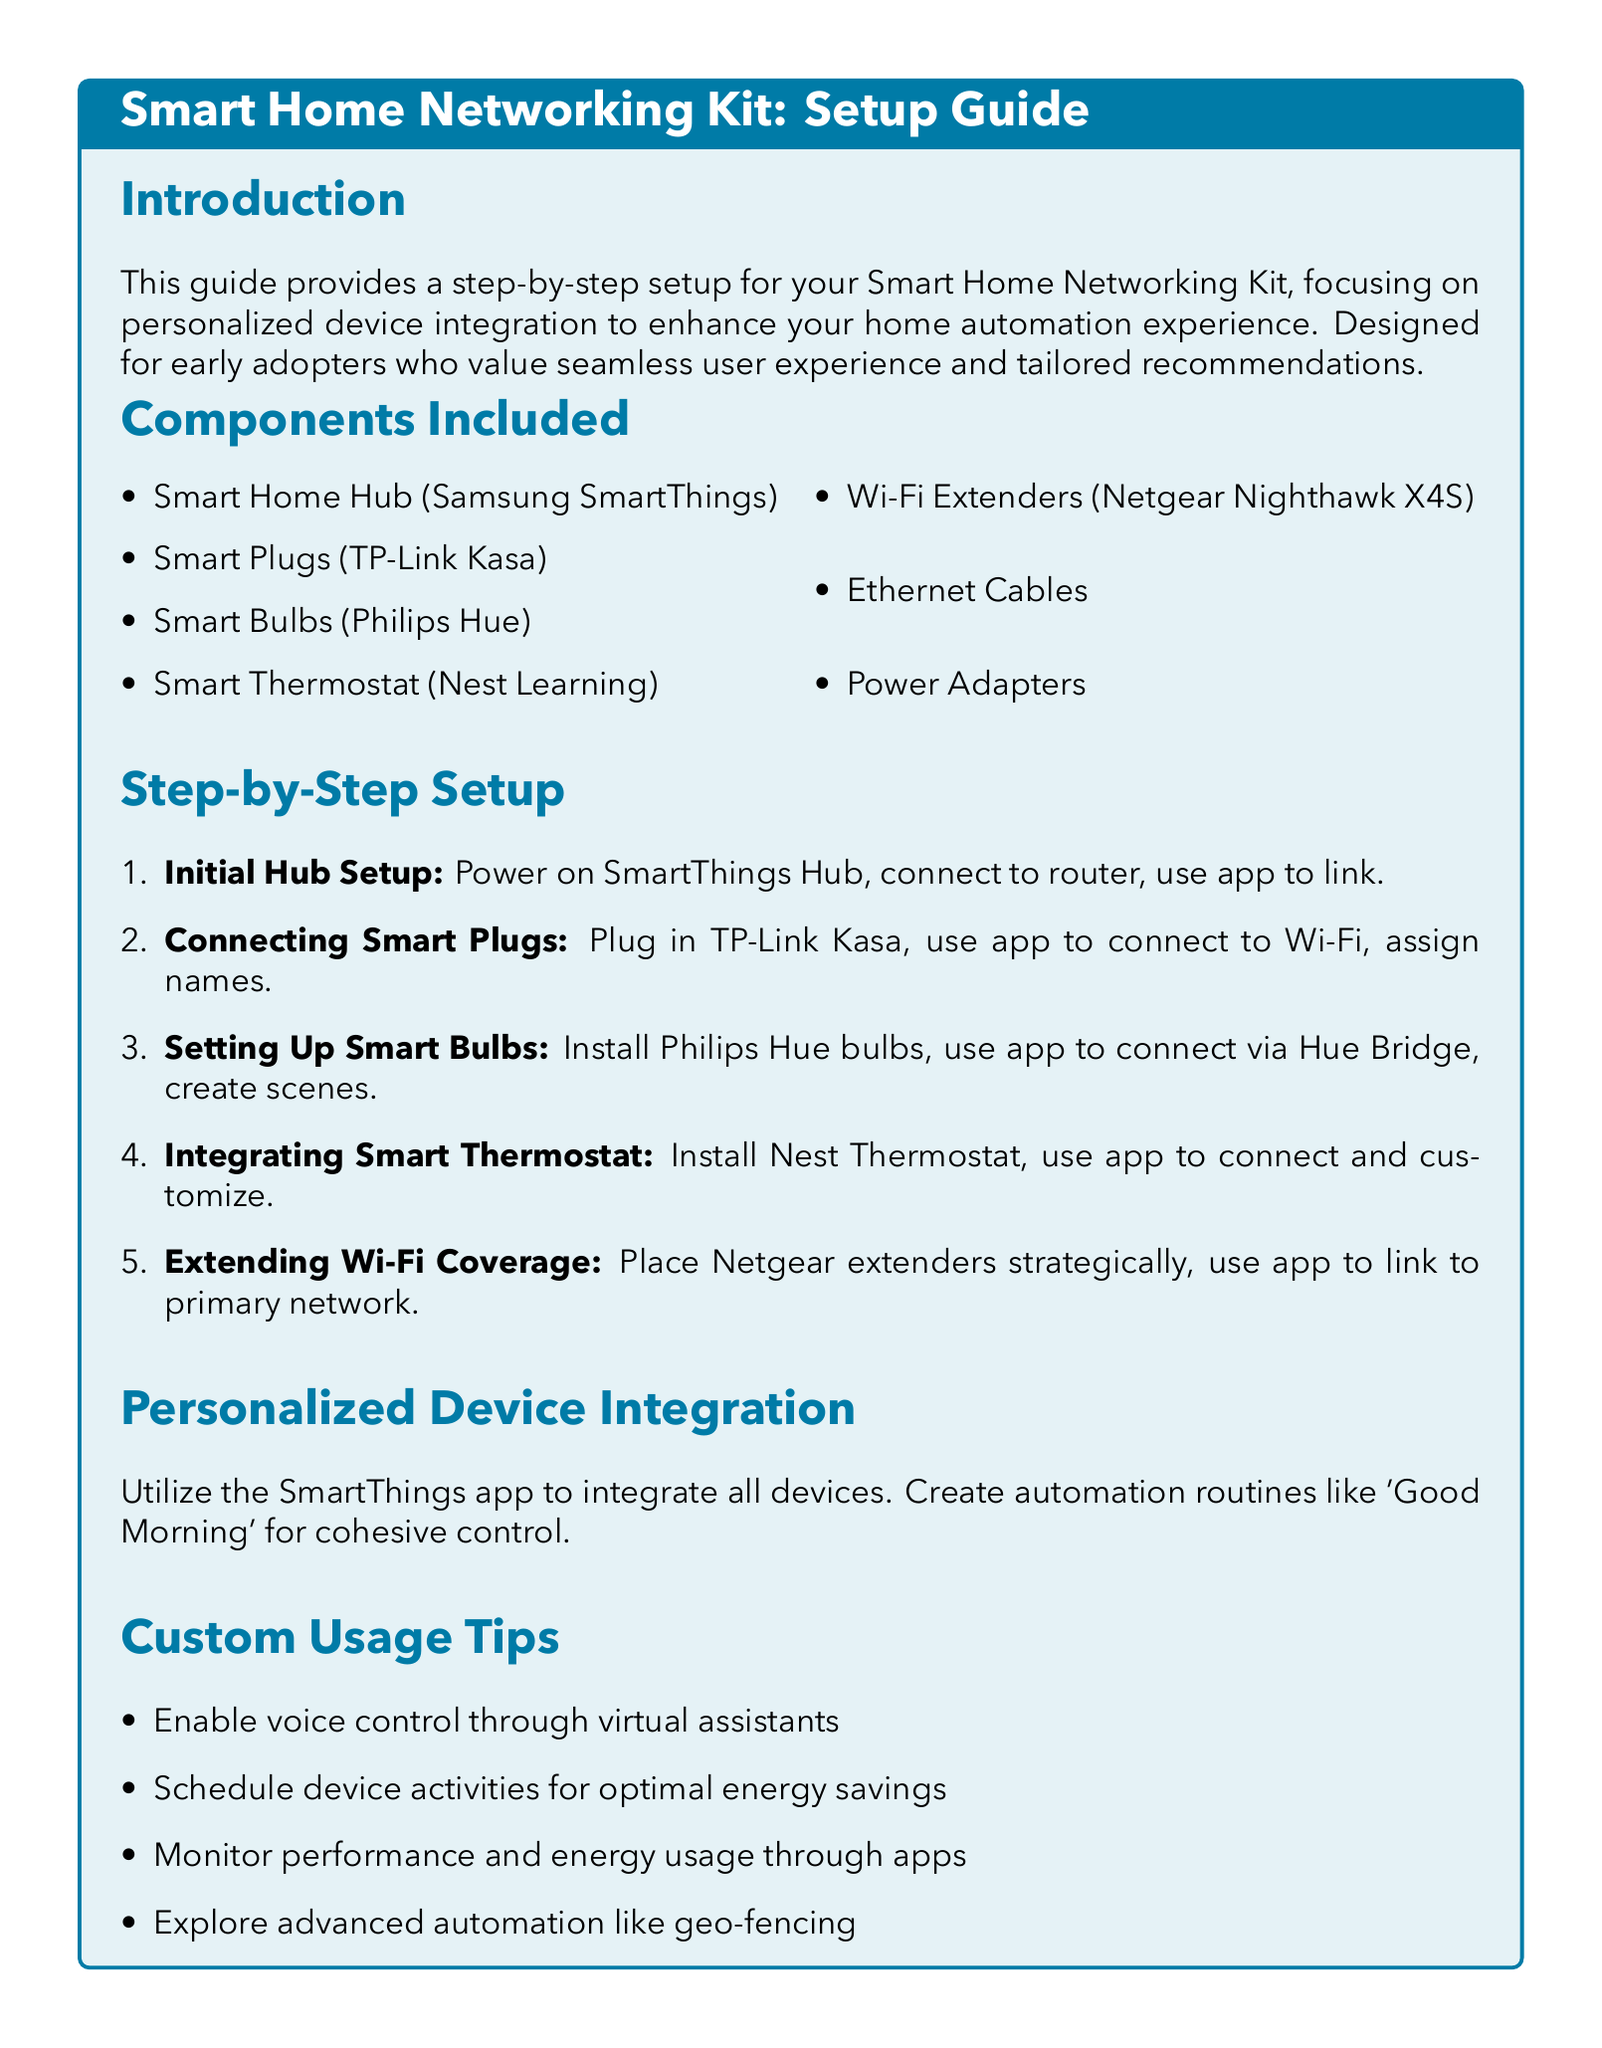What is the first step in the setup? The first step in the setup is the initial hub setup, which involves powering on the SmartThings Hub and connecting it to the router.
Answer: Initial Hub Setup How many components are included in the kit? The document lists seven components included in the Smart Home Networking Kit.
Answer: Seven What type of smart bulbs are included? The document specifies that Philips Hue smart bulbs are included in the kit.
Answer: Philips Hue Which app is used for device integration? The guide states that the SmartThings app is used for integrating all devices.
Answer: SmartThings app What is one of the custom usage tips? The document mentions enabling voice control through virtual assistants as a custom usage tip.
Answer: Enable voice control What device is used to extend Wi-Fi coverage? The document indicates that the Netgear Nighthawk X4S is used as a Wi-Fi extender.
Answer: Netgear Nighthawk X4S What routine can be created for automation? The guide suggests creating a 'Good Morning' routine for cohesive control of devices.
Answer: Good Morning What is the purpose of the Smart Home Networking Kit? The primary purpose is to enhance home automation experience through personalized device integration.
Answer: Enhance home automation experience What is the final step for Wi-Fi extenders? The final step involves linking the extenders to the primary network using the app.
Answer: Link to primary network 